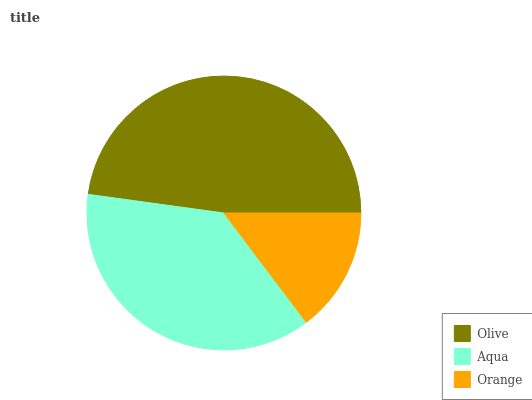Is Orange the minimum?
Answer yes or no. Yes. Is Olive the maximum?
Answer yes or no. Yes. Is Aqua the minimum?
Answer yes or no. No. Is Aqua the maximum?
Answer yes or no. No. Is Olive greater than Aqua?
Answer yes or no. Yes. Is Aqua less than Olive?
Answer yes or no. Yes. Is Aqua greater than Olive?
Answer yes or no. No. Is Olive less than Aqua?
Answer yes or no. No. Is Aqua the high median?
Answer yes or no. Yes. Is Aqua the low median?
Answer yes or no. Yes. Is Olive the high median?
Answer yes or no. No. Is Olive the low median?
Answer yes or no. No. 